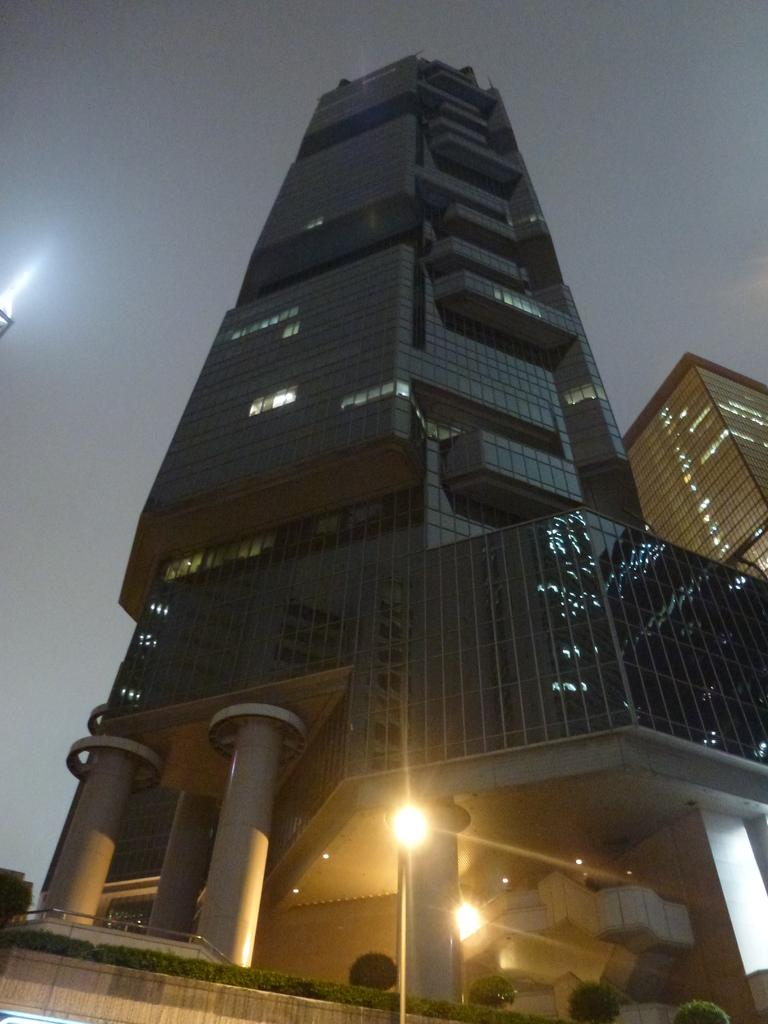What type of buildings are present in the image? There are glass buildings in the image. What architectural feature can be seen in the image? There are pillars in the image. What can be used for illumination in the image? There are lights in the image. What type of vegetation is present in the image? There are trees and plants in the image. What is visible in the sky in the image? The sky is visible in the image. What arithmetic problem can be solved using the tin ornament in the image? There is no tin ornament present in the image, and therefore no arithmetic problem can be solved using it. 